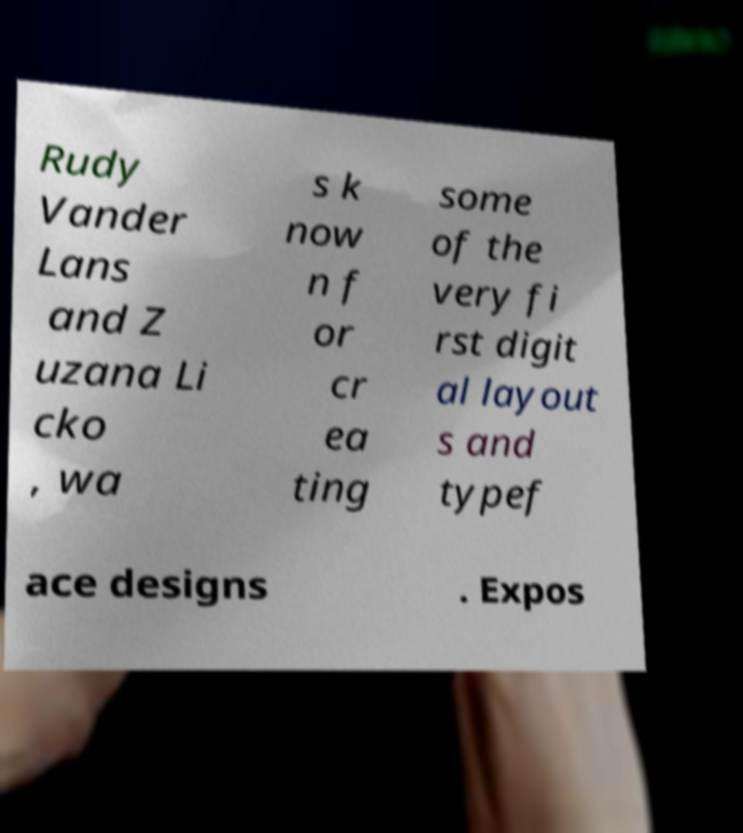Can you read and provide the text displayed in the image?This photo seems to have some interesting text. Can you extract and type it out for me? Rudy Vander Lans and Z uzana Li cko , wa s k now n f or cr ea ting some of the very fi rst digit al layout s and typef ace designs . Expos 